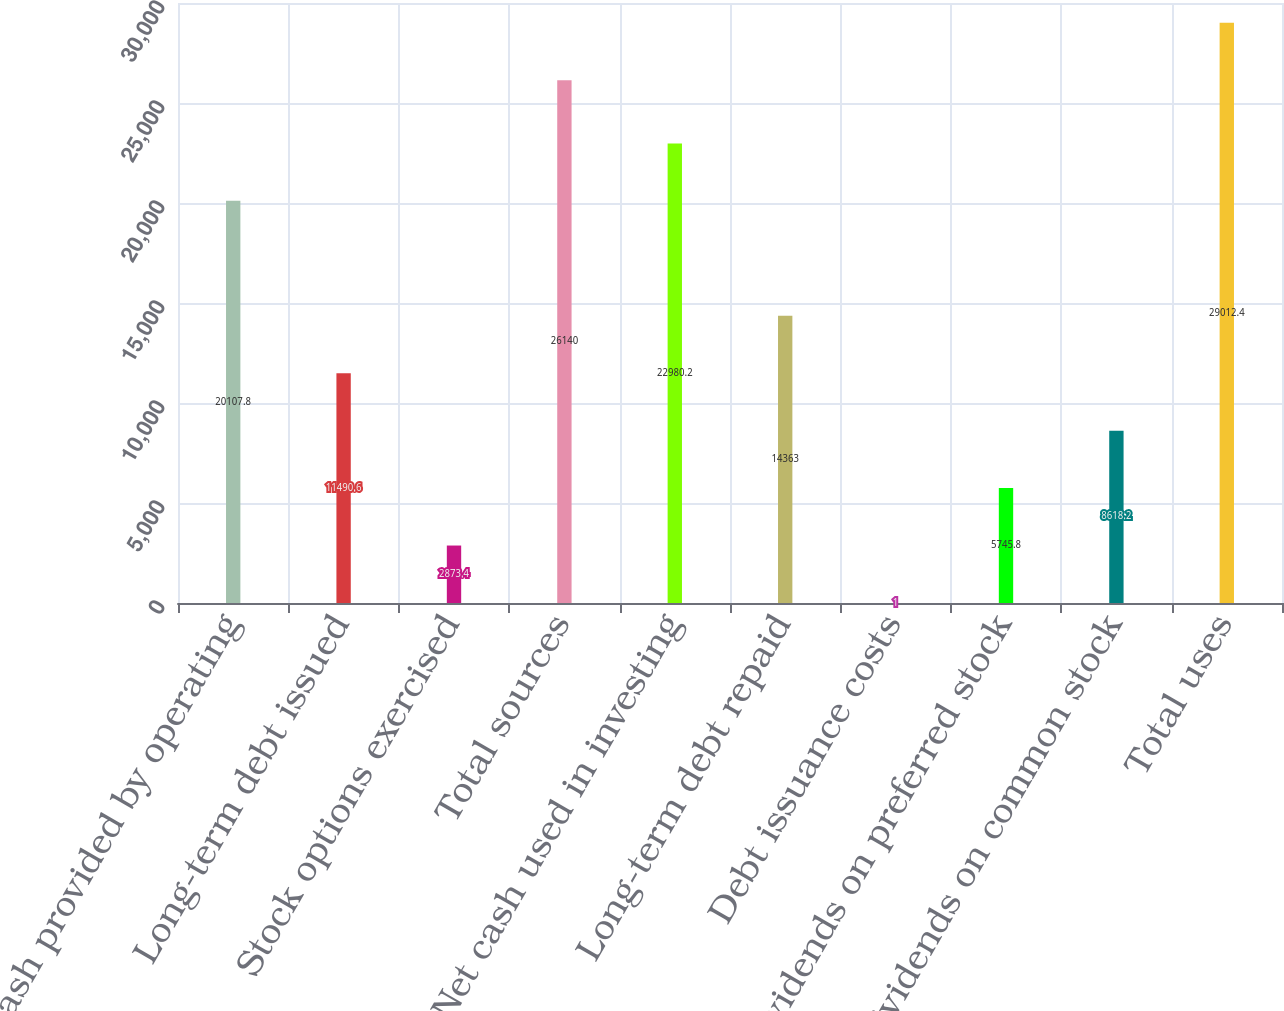Convert chart. <chart><loc_0><loc_0><loc_500><loc_500><bar_chart><fcel>Net cash provided by operating<fcel>Long-term debt issued<fcel>Stock options exercised<fcel>Total sources<fcel>Net cash used in investing<fcel>Long-term debt repaid<fcel>Debt issuance costs<fcel>Dividends on preferred stock<fcel>Dividends on common stock<fcel>Total uses<nl><fcel>20107.8<fcel>11490.6<fcel>2873.4<fcel>26140<fcel>22980.2<fcel>14363<fcel>1<fcel>5745.8<fcel>8618.2<fcel>29012.4<nl></chart> 